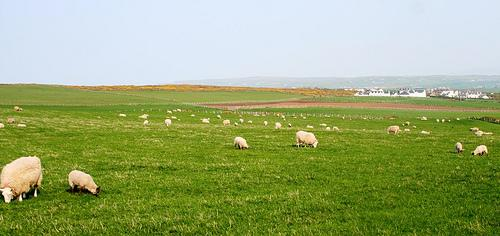Question: what color are the sheep?
Choices:
A. Grey.
B. Black.
C. Brown.
D. White.
Answer with the letter. Answer: D Question: where was this photo taken?
Choices:
A. Under water.
B. Flower garden.
C. Hospital.
D. In a field.
Answer with the letter. Answer: D Question: why was this photo taken?
Choices:
A. To show the ghost.
B. To show the sheep in a field.
C. To see of there are spirits.
D. For memories.
Answer with the letter. Answer: B Question: what color is the grass?
Choices:
A. Purple.
B. Yellow.
C. Black.
D. It is green.
Answer with the letter. Answer: D 